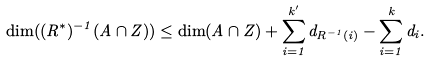Convert formula to latex. <formula><loc_0><loc_0><loc_500><loc_500>\dim ( ( R ^ { * } ) ^ { - 1 } ( A \cap Z ) ) \leq \dim ( A \cap Z ) + \sum _ { i = 1 } ^ { k ^ { \prime } } d _ { R ^ { - 1 } ( i ) } - \sum _ { i = 1 } ^ { k } d _ { i } .</formula> 